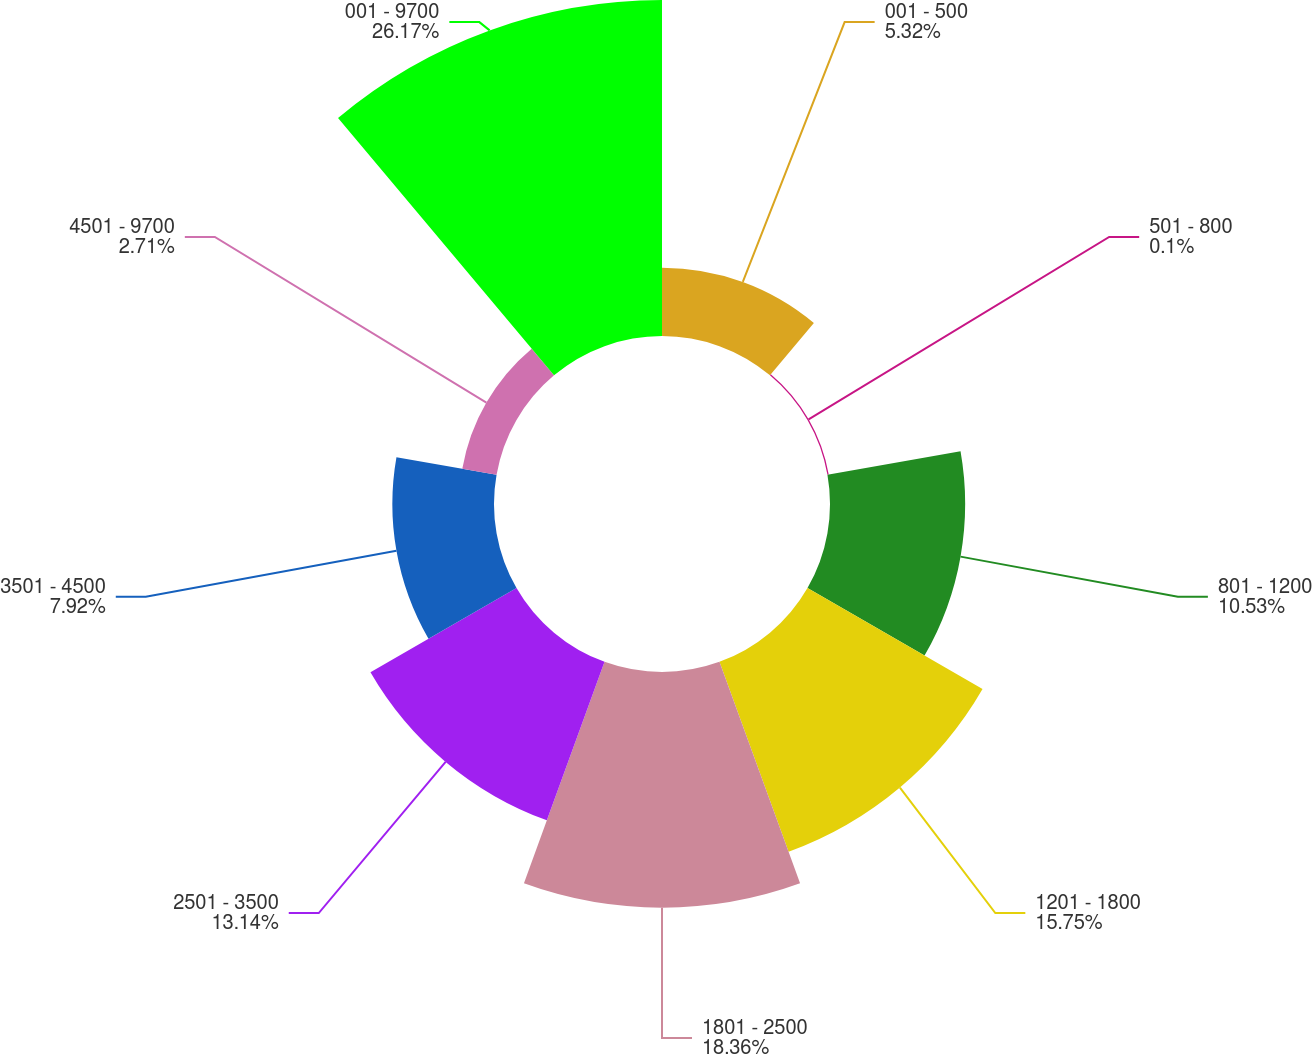Convert chart. <chart><loc_0><loc_0><loc_500><loc_500><pie_chart><fcel>001 - 500<fcel>501 - 800<fcel>801 - 1200<fcel>1201 - 1800<fcel>1801 - 2500<fcel>2501 - 3500<fcel>3501 - 4500<fcel>4501 - 9700<fcel>001 - 9700<nl><fcel>5.32%<fcel>0.1%<fcel>10.53%<fcel>15.75%<fcel>18.36%<fcel>13.14%<fcel>7.92%<fcel>2.71%<fcel>26.18%<nl></chart> 